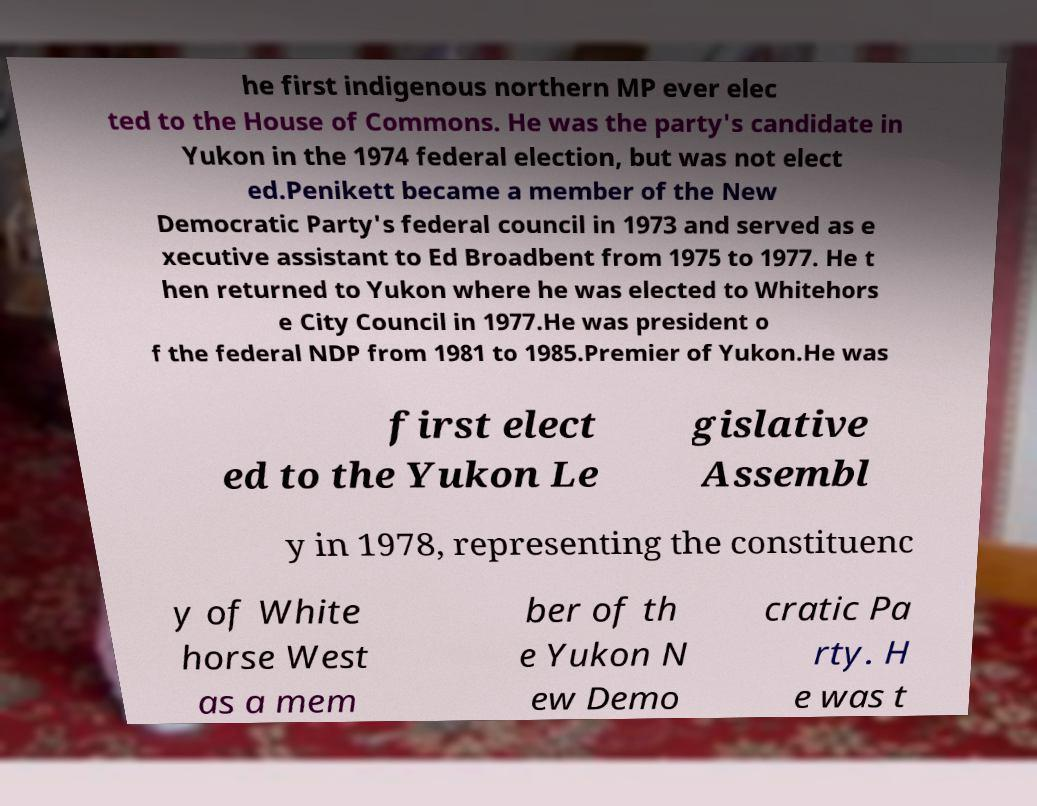Could you extract and type out the text from this image? he first indigenous northern MP ever elec ted to the House of Commons. He was the party's candidate in Yukon in the 1974 federal election, but was not elect ed.Penikett became a member of the New Democratic Party's federal council in 1973 and served as e xecutive assistant to Ed Broadbent from 1975 to 1977. He t hen returned to Yukon where he was elected to Whitehors e City Council in 1977.He was president o f the federal NDP from 1981 to 1985.Premier of Yukon.He was first elect ed to the Yukon Le gislative Assembl y in 1978, representing the constituenc y of White horse West as a mem ber of th e Yukon N ew Demo cratic Pa rty. H e was t 